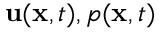Convert formula to latex. <formula><loc_0><loc_0><loc_500><loc_500>{ u } ( { x } , t ) , p ( { x } , t )</formula> 